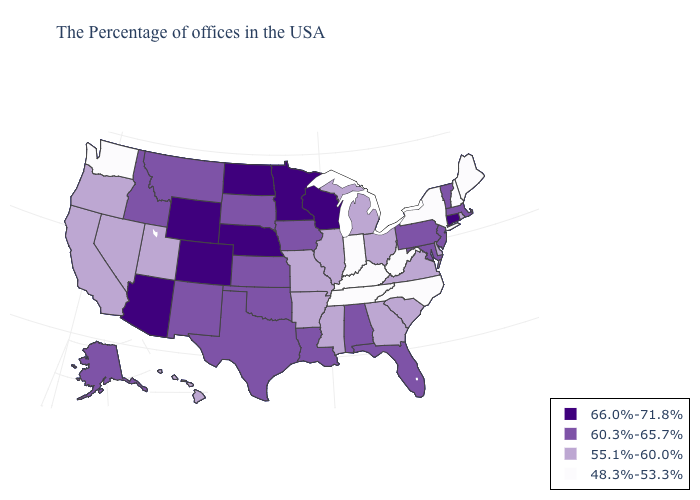What is the highest value in the USA?
Be succinct. 66.0%-71.8%. Which states have the lowest value in the West?
Be succinct. Washington. What is the value of Texas?
Short answer required. 60.3%-65.7%. Name the states that have a value in the range 60.3%-65.7%?
Write a very short answer. Massachusetts, Vermont, New Jersey, Maryland, Pennsylvania, Florida, Alabama, Louisiana, Iowa, Kansas, Oklahoma, Texas, South Dakota, New Mexico, Montana, Idaho, Alaska. What is the lowest value in states that border Iowa?
Short answer required. 55.1%-60.0%. What is the value of Delaware?
Write a very short answer. 55.1%-60.0%. What is the value of Oregon?
Concise answer only. 55.1%-60.0%. Does Wisconsin have the lowest value in the MidWest?
Give a very brief answer. No. What is the value of Idaho?
Write a very short answer. 60.3%-65.7%. Among the states that border South Dakota , which have the lowest value?
Give a very brief answer. Iowa, Montana. How many symbols are there in the legend?
Concise answer only. 4. How many symbols are there in the legend?
Write a very short answer. 4. Among the states that border Vermont , which have the lowest value?
Keep it brief. New Hampshire, New York. Which states have the highest value in the USA?
Be succinct. Connecticut, Wisconsin, Minnesota, Nebraska, North Dakota, Wyoming, Colorado, Arizona. Name the states that have a value in the range 55.1%-60.0%?
Keep it brief. Rhode Island, Delaware, Virginia, South Carolina, Ohio, Georgia, Michigan, Illinois, Mississippi, Missouri, Arkansas, Utah, Nevada, California, Oregon, Hawaii. 